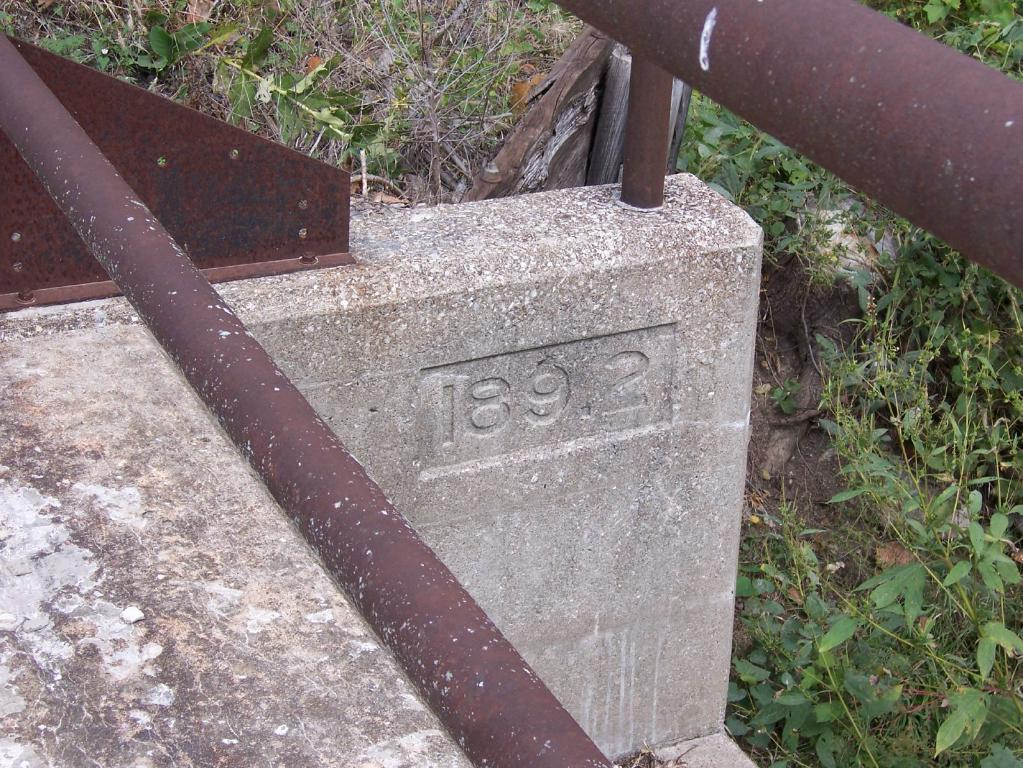What is the main object in the image with numbers on it? There is a stone with numbers in the image. What type of material are the rods made of in the image? The rods in the image are made of iron. What is the wooden object in the image? There is a wooden object in the image, but its specific purpose or appearance is not mentioned. What can be seen in the background of the image? In the background of the image, there are plants and grass. Can you tell me what the girl is doing in the image? There is no girl present in the image. What sense is being stimulated by the wooden object in the image? The provided facts do not mention any sensory aspect related to the wooden object, so it is impossible to determine which sense is being stimulated. 